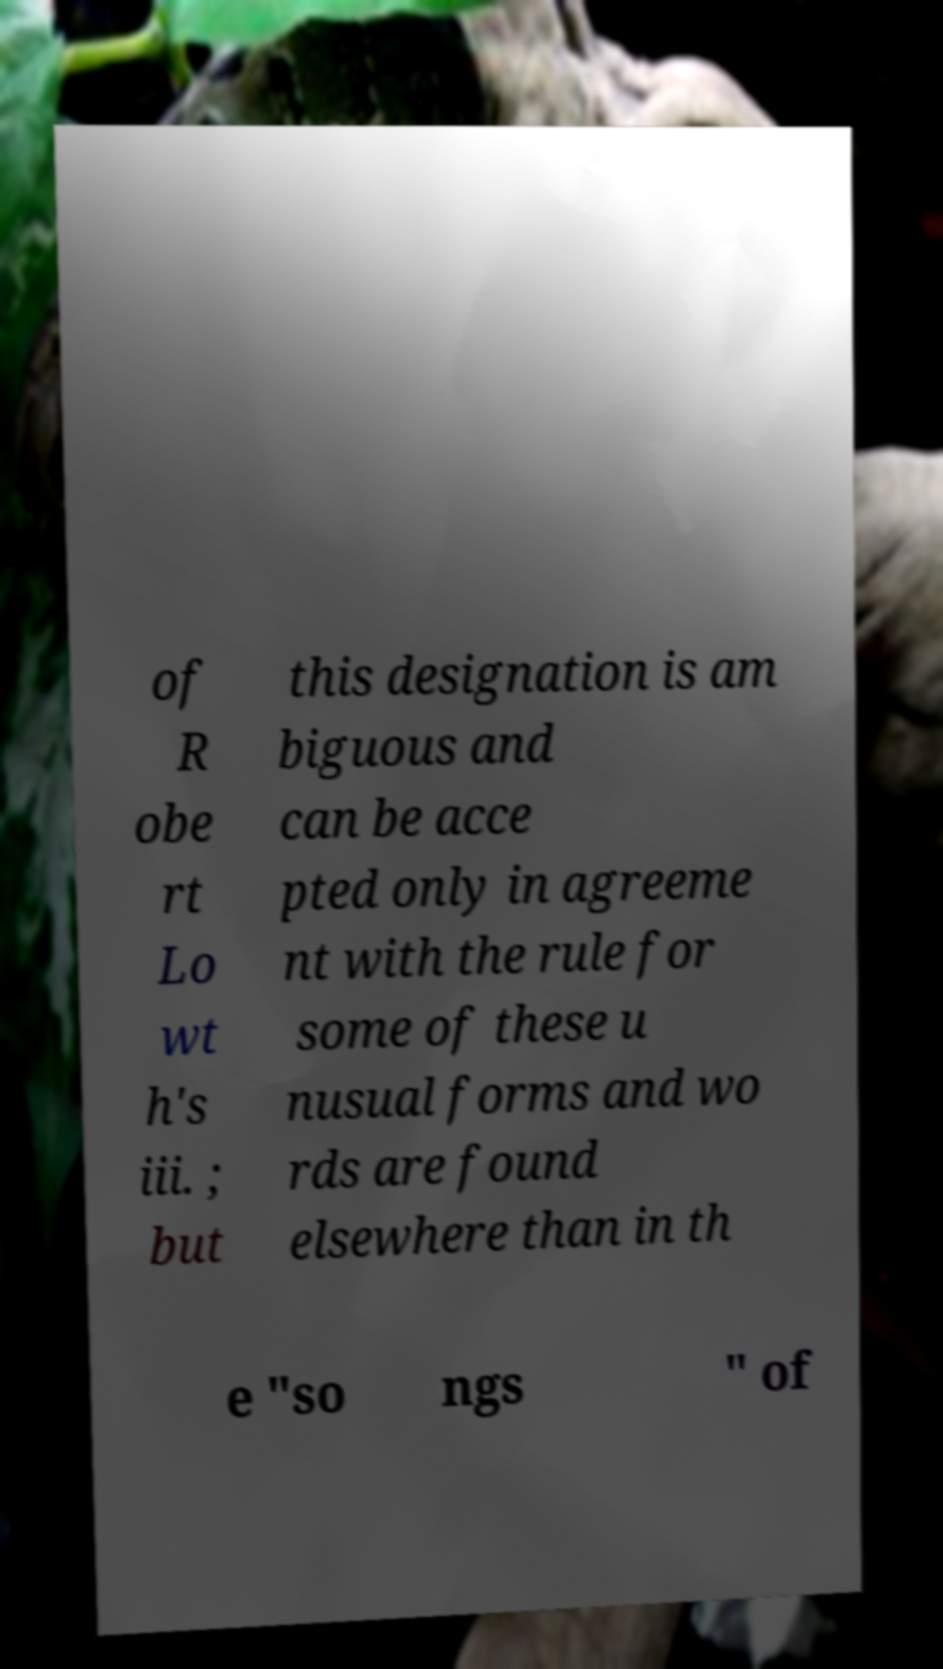Can you accurately transcribe the text from the provided image for me? of R obe rt Lo wt h's iii. ; but this designation is am biguous and can be acce pted only in agreeme nt with the rule for some of these u nusual forms and wo rds are found elsewhere than in th e "so ngs " of 